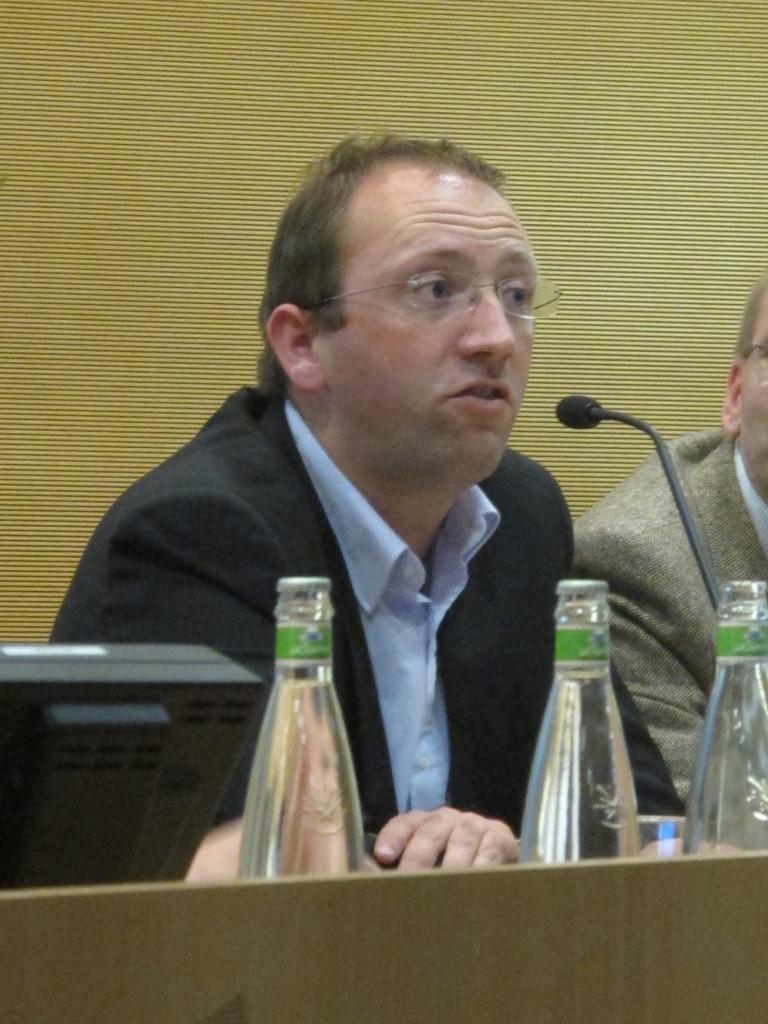In one or two sentences, can you explain what this image depicts? This picture shows two men seated and we see a microphone and three bottles and a monitor on the table and the man speaking with the help of a microphone 